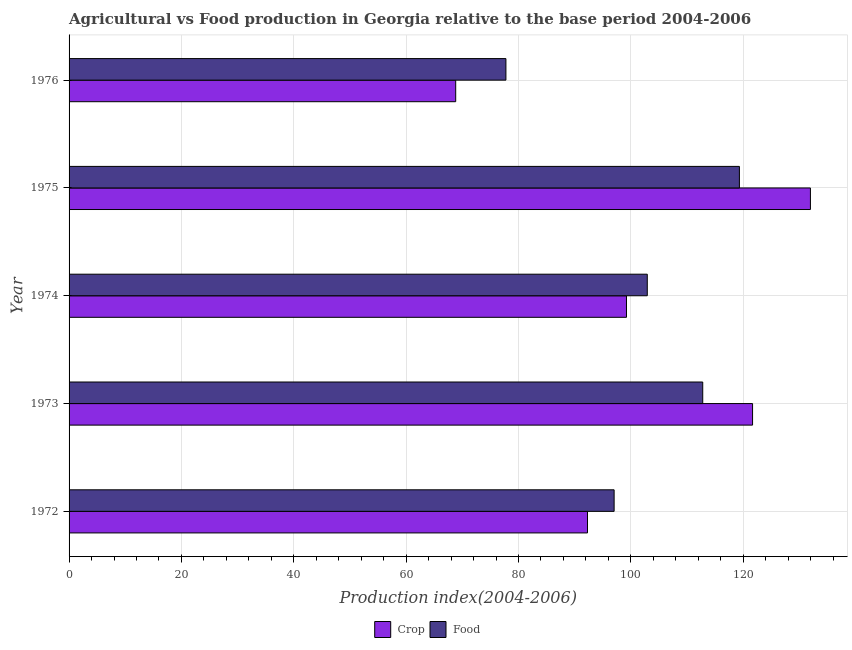How many different coloured bars are there?
Offer a terse response. 2. How many groups of bars are there?
Provide a short and direct response. 5. How many bars are there on the 2nd tick from the top?
Make the answer very short. 2. How many bars are there on the 4th tick from the bottom?
Offer a very short reply. 2. What is the label of the 2nd group of bars from the top?
Keep it short and to the point. 1975. In how many cases, is the number of bars for a given year not equal to the number of legend labels?
Give a very brief answer. 0. What is the food production index in 1973?
Make the answer very short. 112.79. Across all years, what is the maximum food production index?
Your answer should be very brief. 119.32. Across all years, what is the minimum food production index?
Keep it short and to the point. 77.76. In which year was the crop production index maximum?
Offer a very short reply. 1975. In which year was the food production index minimum?
Keep it short and to the point. 1976. What is the total food production index in the graph?
Provide a succinct answer. 509.81. What is the difference between the crop production index in 1975 and that in 1976?
Your response must be concise. 63.14. What is the difference between the crop production index in 1976 and the food production index in 1974?
Offer a very short reply. -34.1. What is the average crop production index per year?
Make the answer very short. 102.79. In the year 1973, what is the difference between the crop production index and food production index?
Provide a succinct answer. 8.87. In how many years, is the food production index greater than 56 ?
Keep it short and to the point. 5. What is the ratio of the food production index in 1972 to that in 1974?
Keep it short and to the point. 0.94. What is the difference between the highest and the second highest food production index?
Offer a very short reply. 6.53. What is the difference between the highest and the lowest crop production index?
Offer a terse response. 63.14. What does the 2nd bar from the top in 1974 represents?
Your response must be concise. Crop. What does the 1st bar from the bottom in 1975 represents?
Give a very brief answer. Crop. How many bars are there?
Offer a very short reply. 10. Are all the bars in the graph horizontal?
Give a very brief answer. Yes. What is the difference between two consecutive major ticks on the X-axis?
Offer a terse response. 20. Are the values on the major ticks of X-axis written in scientific E-notation?
Offer a terse response. No. What is the title of the graph?
Offer a very short reply. Agricultural vs Food production in Georgia relative to the base period 2004-2006. What is the label or title of the X-axis?
Your answer should be compact. Production index(2004-2006). What is the Production index(2004-2006) in Crop in 1972?
Make the answer very short. 92.28. What is the Production index(2004-2006) in Food in 1972?
Keep it short and to the point. 97.02. What is the Production index(2004-2006) in Crop in 1973?
Keep it short and to the point. 121.66. What is the Production index(2004-2006) in Food in 1973?
Provide a short and direct response. 112.79. What is the Production index(2004-2006) of Crop in 1974?
Give a very brief answer. 99.22. What is the Production index(2004-2006) of Food in 1974?
Provide a short and direct response. 102.92. What is the Production index(2004-2006) of Crop in 1975?
Your response must be concise. 131.96. What is the Production index(2004-2006) in Food in 1975?
Give a very brief answer. 119.32. What is the Production index(2004-2006) in Crop in 1976?
Give a very brief answer. 68.82. What is the Production index(2004-2006) in Food in 1976?
Offer a terse response. 77.76. Across all years, what is the maximum Production index(2004-2006) in Crop?
Make the answer very short. 131.96. Across all years, what is the maximum Production index(2004-2006) of Food?
Keep it short and to the point. 119.32. Across all years, what is the minimum Production index(2004-2006) of Crop?
Make the answer very short. 68.82. Across all years, what is the minimum Production index(2004-2006) of Food?
Offer a very short reply. 77.76. What is the total Production index(2004-2006) in Crop in the graph?
Offer a very short reply. 513.94. What is the total Production index(2004-2006) in Food in the graph?
Your answer should be compact. 509.81. What is the difference between the Production index(2004-2006) of Crop in 1972 and that in 1973?
Make the answer very short. -29.38. What is the difference between the Production index(2004-2006) in Food in 1972 and that in 1973?
Your answer should be very brief. -15.77. What is the difference between the Production index(2004-2006) in Crop in 1972 and that in 1974?
Keep it short and to the point. -6.94. What is the difference between the Production index(2004-2006) in Food in 1972 and that in 1974?
Keep it short and to the point. -5.9. What is the difference between the Production index(2004-2006) of Crop in 1972 and that in 1975?
Your answer should be very brief. -39.68. What is the difference between the Production index(2004-2006) of Food in 1972 and that in 1975?
Provide a short and direct response. -22.3. What is the difference between the Production index(2004-2006) of Crop in 1972 and that in 1976?
Keep it short and to the point. 23.46. What is the difference between the Production index(2004-2006) in Food in 1972 and that in 1976?
Ensure brevity in your answer.  19.26. What is the difference between the Production index(2004-2006) in Crop in 1973 and that in 1974?
Provide a short and direct response. 22.44. What is the difference between the Production index(2004-2006) of Food in 1973 and that in 1974?
Give a very brief answer. 9.87. What is the difference between the Production index(2004-2006) of Food in 1973 and that in 1975?
Make the answer very short. -6.53. What is the difference between the Production index(2004-2006) in Crop in 1973 and that in 1976?
Ensure brevity in your answer.  52.84. What is the difference between the Production index(2004-2006) of Food in 1973 and that in 1976?
Ensure brevity in your answer.  35.03. What is the difference between the Production index(2004-2006) of Crop in 1974 and that in 1975?
Your answer should be very brief. -32.74. What is the difference between the Production index(2004-2006) of Food in 1974 and that in 1975?
Offer a very short reply. -16.4. What is the difference between the Production index(2004-2006) in Crop in 1974 and that in 1976?
Offer a terse response. 30.4. What is the difference between the Production index(2004-2006) of Food in 1974 and that in 1976?
Your answer should be very brief. 25.16. What is the difference between the Production index(2004-2006) in Crop in 1975 and that in 1976?
Make the answer very short. 63.14. What is the difference between the Production index(2004-2006) in Food in 1975 and that in 1976?
Offer a terse response. 41.56. What is the difference between the Production index(2004-2006) of Crop in 1972 and the Production index(2004-2006) of Food in 1973?
Ensure brevity in your answer.  -20.51. What is the difference between the Production index(2004-2006) of Crop in 1972 and the Production index(2004-2006) of Food in 1974?
Make the answer very short. -10.64. What is the difference between the Production index(2004-2006) of Crop in 1972 and the Production index(2004-2006) of Food in 1975?
Keep it short and to the point. -27.04. What is the difference between the Production index(2004-2006) in Crop in 1972 and the Production index(2004-2006) in Food in 1976?
Give a very brief answer. 14.52. What is the difference between the Production index(2004-2006) of Crop in 1973 and the Production index(2004-2006) of Food in 1974?
Your response must be concise. 18.74. What is the difference between the Production index(2004-2006) in Crop in 1973 and the Production index(2004-2006) in Food in 1975?
Keep it short and to the point. 2.34. What is the difference between the Production index(2004-2006) of Crop in 1973 and the Production index(2004-2006) of Food in 1976?
Your response must be concise. 43.9. What is the difference between the Production index(2004-2006) in Crop in 1974 and the Production index(2004-2006) in Food in 1975?
Ensure brevity in your answer.  -20.1. What is the difference between the Production index(2004-2006) of Crop in 1974 and the Production index(2004-2006) of Food in 1976?
Ensure brevity in your answer.  21.46. What is the difference between the Production index(2004-2006) in Crop in 1975 and the Production index(2004-2006) in Food in 1976?
Your answer should be compact. 54.2. What is the average Production index(2004-2006) of Crop per year?
Give a very brief answer. 102.79. What is the average Production index(2004-2006) of Food per year?
Ensure brevity in your answer.  101.96. In the year 1972, what is the difference between the Production index(2004-2006) of Crop and Production index(2004-2006) of Food?
Your response must be concise. -4.74. In the year 1973, what is the difference between the Production index(2004-2006) of Crop and Production index(2004-2006) of Food?
Your response must be concise. 8.87. In the year 1974, what is the difference between the Production index(2004-2006) of Crop and Production index(2004-2006) of Food?
Provide a short and direct response. -3.7. In the year 1975, what is the difference between the Production index(2004-2006) in Crop and Production index(2004-2006) in Food?
Give a very brief answer. 12.64. In the year 1976, what is the difference between the Production index(2004-2006) in Crop and Production index(2004-2006) in Food?
Offer a terse response. -8.94. What is the ratio of the Production index(2004-2006) in Crop in 1972 to that in 1973?
Offer a terse response. 0.76. What is the ratio of the Production index(2004-2006) of Food in 1972 to that in 1973?
Your response must be concise. 0.86. What is the ratio of the Production index(2004-2006) of Crop in 1972 to that in 1974?
Keep it short and to the point. 0.93. What is the ratio of the Production index(2004-2006) in Food in 1972 to that in 1974?
Make the answer very short. 0.94. What is the ratio of the Production index(2004-2006) in Crop in 1972 to that in 1975?
Make the answer very short. 0.7. What is the ratio of the Production index(2004-2006) in Food in 1972 to that in 1975?
Make the answer very short. 0.81. What is the ratio of the Production index(2004-2006) of Crop in 1972 to that in 1976?
Give a very brief answer. 1.34. What is the ratio of the Production index(2004-2006) in Food in 1972 to that in 1976?
Provide a short and direct response. 1.25. What is the ratio of the Production index(2004-2006) in Crop in 1973 to that in 1974?
Keep it short and to the point. 1.23. What is the ratio of the Production index(2004-2006) in Food in 1973 to that in 1974?
Your response must be concise. 1.1. What is the ratio of the Production index(2004-2006) of Crop in 1973 to that in 1975?
Your answer should be very brief. 0.92. What is the ratio of the Production index(2004-2006) in Food in 1973 to that in 1975?
Your answer should be compact. 0.95. What is the ratio of the Production index(2004-2006) of Crop in 1973 to that in 1976?
Your answer should be very brief. 1.77. What is the ratio of the Production index(2004-2006) of Food in 1973 to that in 1976?
Ensure brevity in your answer.  1.45. What is the ratio of the Production index(2004-2006) in Crop in 1974 to that in 1975?
Provide a short and direct response. 0.75. What is the ratio of the Production index(2004-2006) in Food in 1974 to that in 1975?
Your answer should be very brief. 0.86. What is the ratio of the Production index(2004-2006) of Crop in 1974 to that in 1976?
Keep it short and to the point. 1.44. What is the ratio of the Production index(2004-2006) of Food in 1974 to that in 1976?
Ensure brevity in your answer.  1.32. What is the ratio of the Production index(2004-2006) of Crop in 1975 to that in 1976?
Give a very brief answer. 1.92. What is the ratio of the Production index(2004-2006) in Food in 1975 to that in 1976?
Your answer should be very brief. 1.53. What is the difference between the highest and the second highest Production index(2004-2006) in Food?
Offer a very short reply. 6.53. What is the difference between the highest and the lowest Production index(2004-2006) of Crop?
Your response must be concise. 63.14. What is the difference between the highest and the lowest Production index(2004-2006) of Food?
Ensure brevity in your answer.  41.56. 